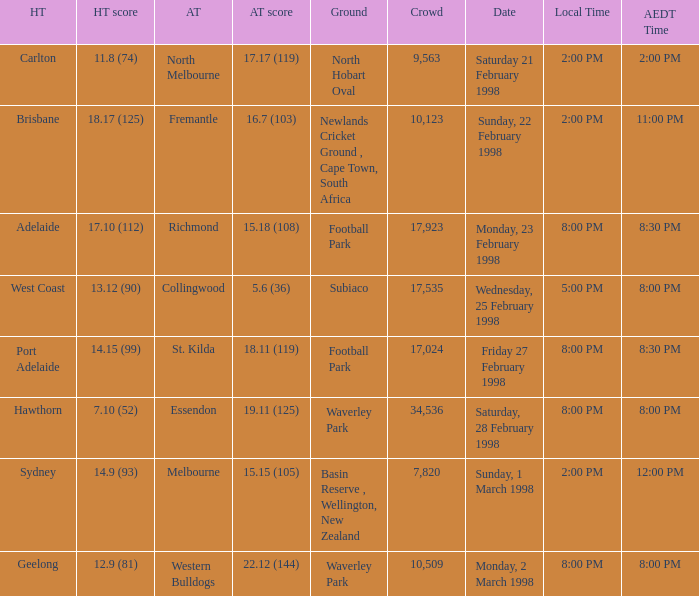Which Home team score has a AEDT Time of 11:00 pm? 18.17 (125). 